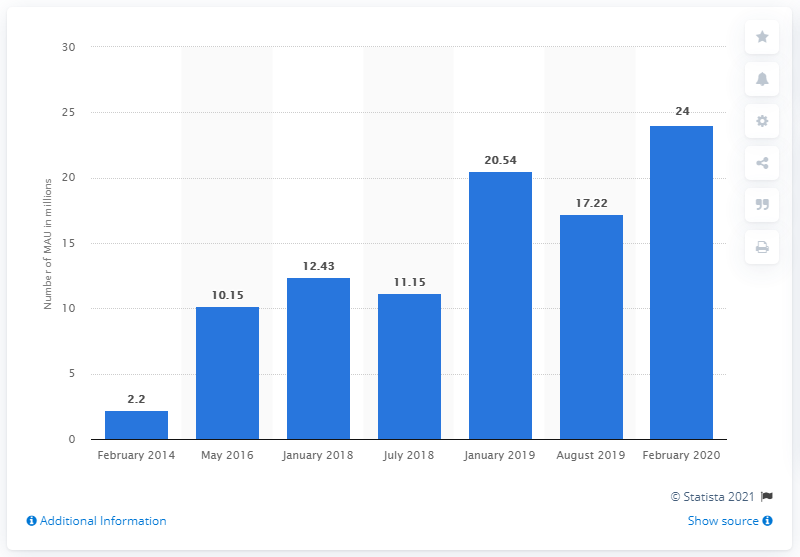Indicate a few pertinent items in this graphic. CS:GO began having a record 24 million monthly active users in February 2020. As of February 2023, the exact number of monthly active users for CS:GO is not publicly disclosed. However, it is estimated that the game had approximately 24 monthly active users at that time. 